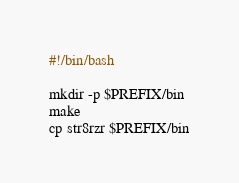Convert code to text. <code><loc_0><loc_0><loc_500><loc_500><_Bash_>#!/bin/bash

mkdir -p $PREFIX/bin
make 
cp str8rzr $PREFIX/bin
</code> 